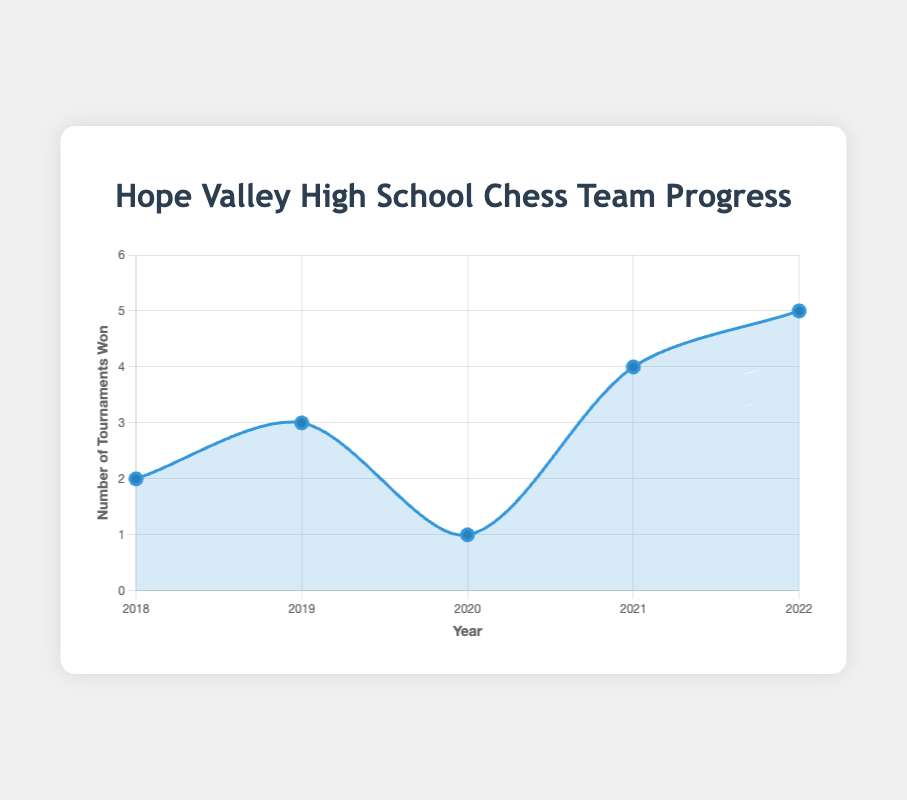What was the average number of tournaments won per year over the 5-year period? The total number of tournaments won over the 5 years is 2 + 3 + 1 + 4 + 5 = 15. The average is 15 divided by 5 years.
Answer: 3 What was the total number of tournaments won in the first and last years combined? The number of tournaments won in 2018 is 2, and in 2022 is 5. The total combined is 2 + 5.
Answer: 7 How many more tournaments were won in 2022 compared to 2020? In 2022, 5 tournaments were won, and in 2020, 1 tournament was won. The difference is 5 - 1.
Answer: 4 Which year had the highest number of tournaments won? By inspecting the data points, the year with the highest number of tournaments won is 2022 with 5 tournaments.
Answer: 2022 How did the number of tournaments won change from 2019 to 2020? In 2019, 3 tournaments were won, and in 2020, 1 tournament was won. The number of tournaments won decreased by 2.
Answer: It decreased by 2 Which two consecutive years had the greatest increase in the number of tournaments won? Comparing consecutive years: 2018-2019 increased by 3-2 = 1, 2019-2020 decreased by 2, 2020-2021 increased by 4-1 = 3, 2021-2022 increased by 1. The greatest increase is from 2020 to 2021.
Answer: 2020 to 2021 In which year did the chess team win the fewest tournaments, and how many tournaments were won that year? By looking at the data points, the year with the fewest tournaments won is 2020, with only 1 tournament won.
Answer: 2020, 1 tournament What is the total number of major tournaments won by the chess team over the 5 years? Summing the major tournaments won each year: 2 (2018) + 3 (2019) + 1 (2020) + 4 (2021) + 5 (2022) = 15 major tournaments.
Answer: 15 Between which years did the number of tournaments won remain the same, if at all? There was no period where the number of tournaments won remained the same between consecutive years; the number of tournaments won changed every year.
Answer: No years 